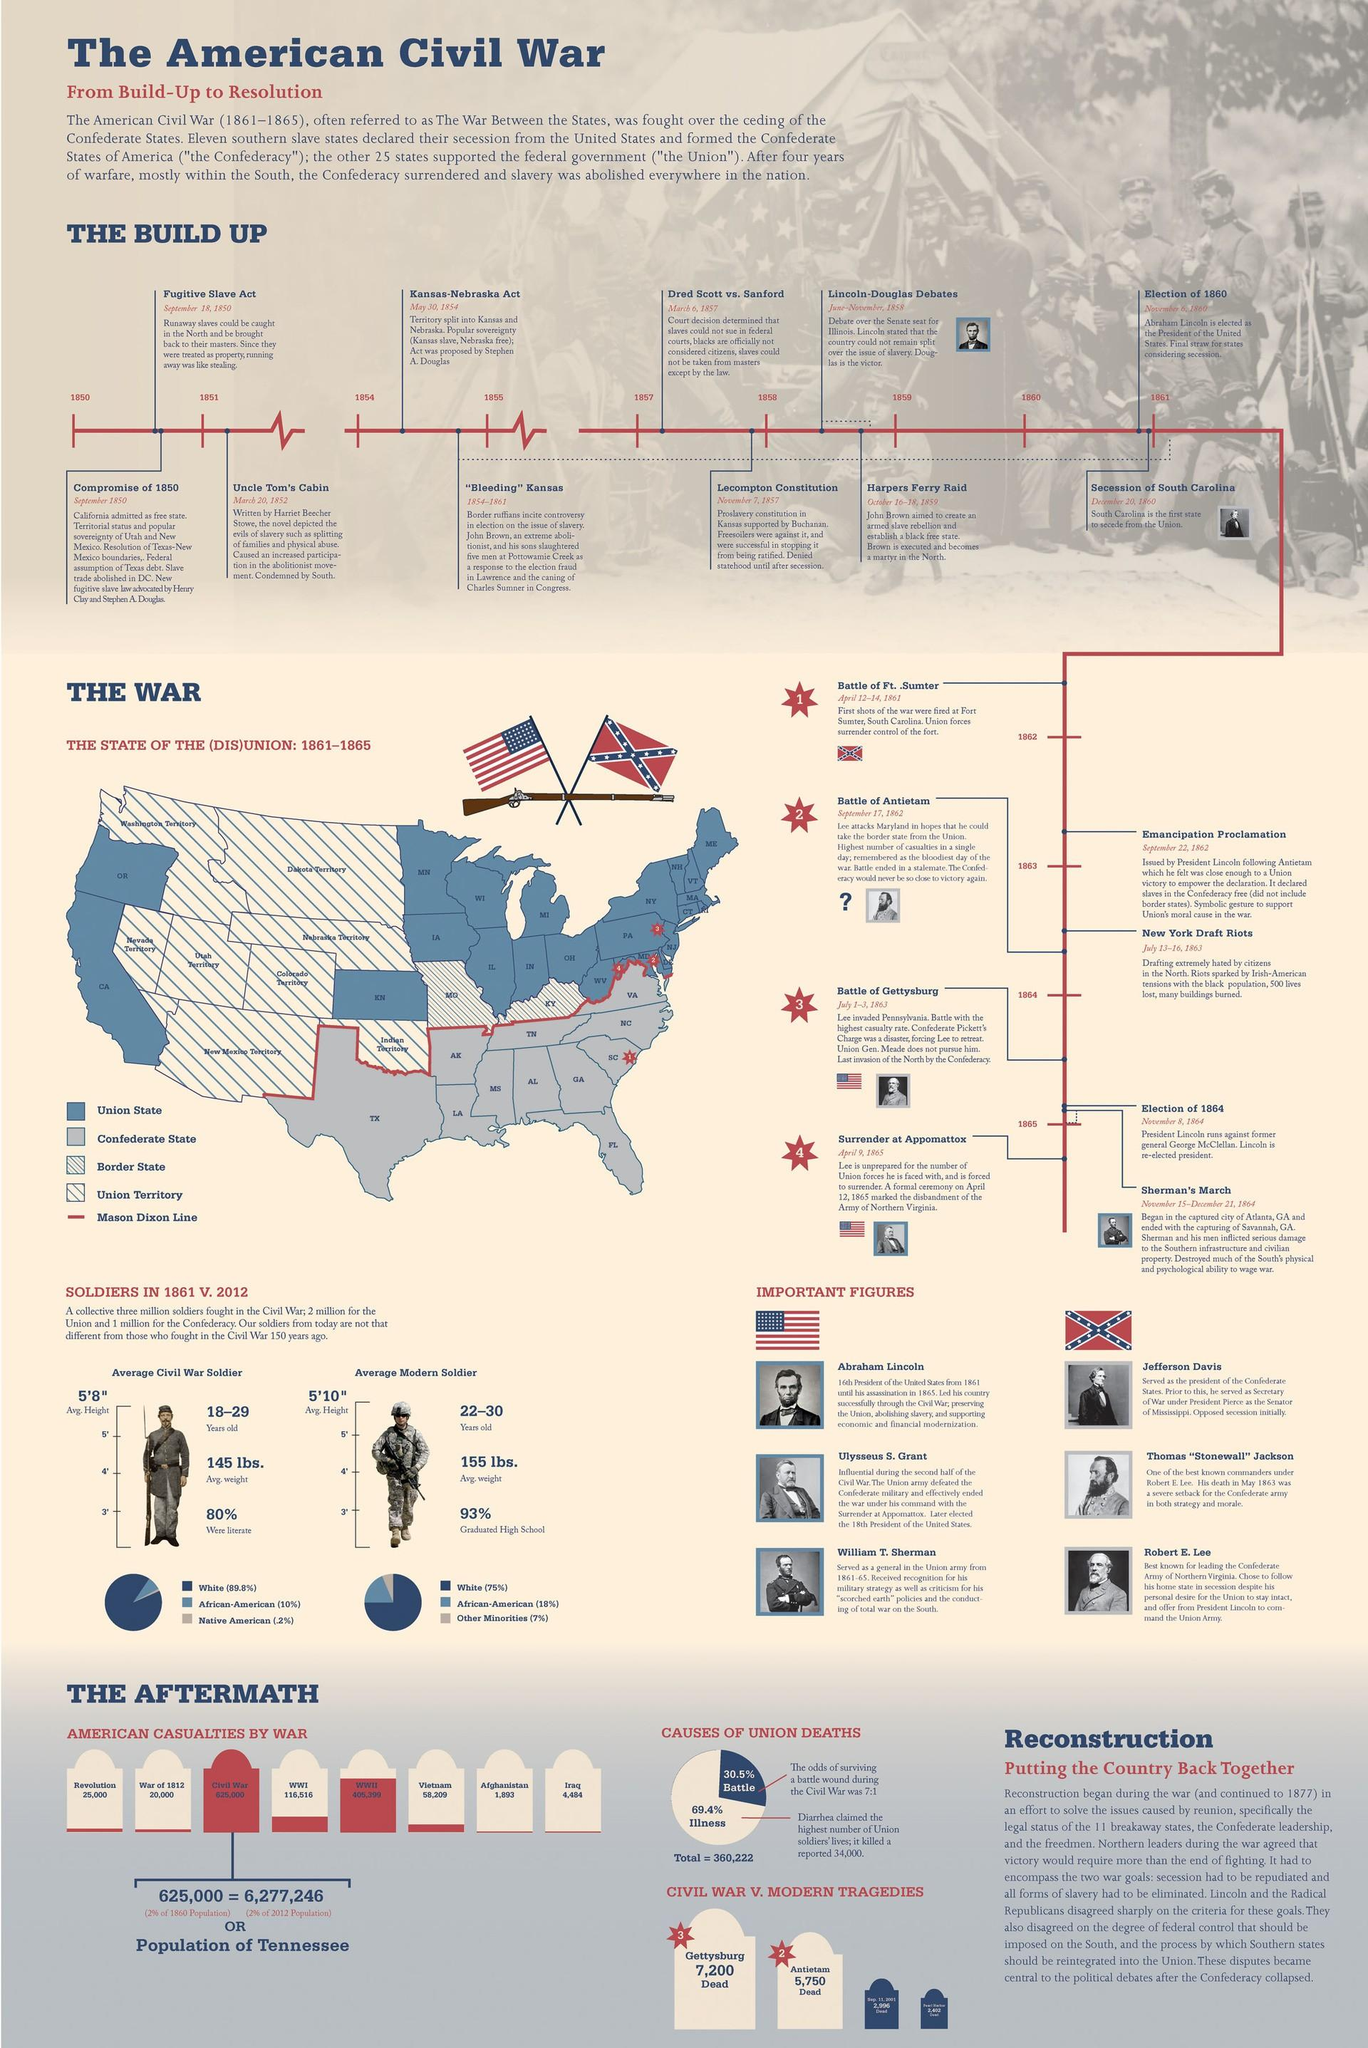Point out several critical features in this image. The average height of a Civil War soldier in 1861 was approximately 5'8" tall. In 2012, approximately 18% of modern soldiers were African-American. South Carolina seceded from the Union on December 20, 1860. During the First World War, a total of 116,516 American casualties were reported. The average weight of a Civil War soldier in 1861 was approximately 145 pounds. 